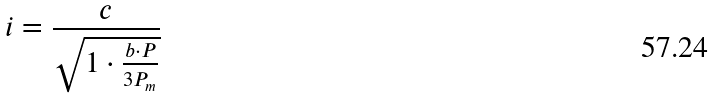Convert formula to latex. <formula><loc_0><loc_0><loc_500><loc_500>i = \frac { c } { \sqrt { 1 \cdot \frac { b \cdot P } { 3 P _ { m } } } }</formula> 